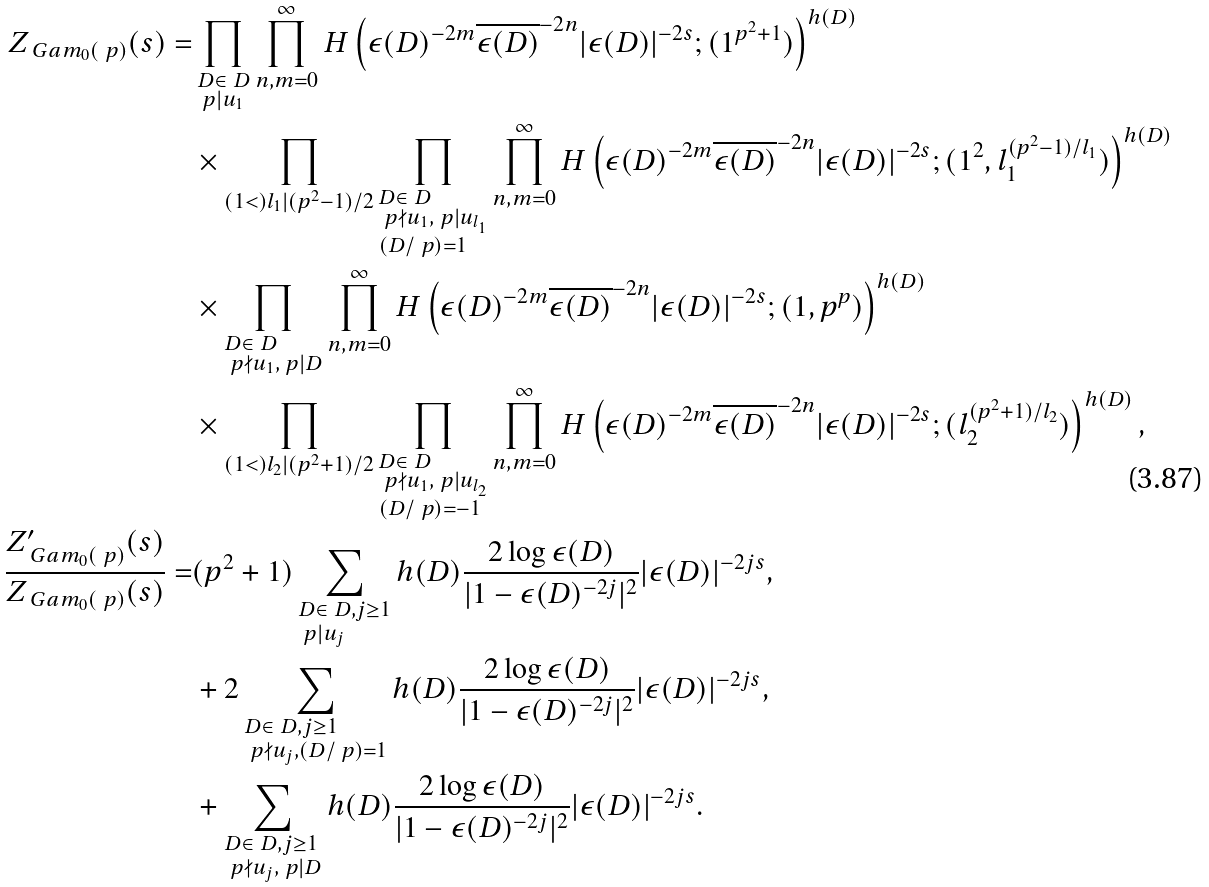Convert formula to latex. <formula><loc_0><loc_0><loc_500><loc_500>Z _ { \ G a m _ { 0 } ( \ p ) } ( s ) = & \prod _ { \begin{subarray} { c } D \in \ D \\ \ p | u _ { 1 } \end{subarray} } \prod _ { n , m = 0 } ^ { \infty } H \left ( \epsilon ( D ) ^ { - 2 m } \overline { \epsilon ( D ) } ^ { - 2 n } | \epsilon ( D ) | ^ { - 2 s } ; ( 1 ^ { p ^ { 2 } + 1 } ) \right ) ^ { h ( D ) } \\ & \times \prod _ { ( 1 < ) l _ { 1 } | ( p ^ { 2 } - 1 ) / 2 } \prod _ { \begin{subarray} { c } D \in \ D \\ \ p \nmid u _ { 1 } , \ p | u _ { l _ { 1 } } \\ ( D / \ p ) = 1 \end{subarray} } \prod _ { n , m = 0 } ^ { \infty } H \left ( \epsilon ( D ) ^ { - 2 m } \overline { \epsilon ( D ) } ^ { - 2 n } | \epsilon ( D ) | ^ { - 2 s } ; ( 1 ^ { 2 } , l _ { 1 } ^ { ( p ^ { 2 } - 1 ) / l _ { 1 } } ) \right ) ^ { h ( D ) } \\ & \times \prod _ { \begin{subarray} { c } D \in \ D \\ \ p \nmid u _ { 1 } , \ p | D \end{subarray} } \prod _ { n , m = 0 } ^ { \infty } H \left ( \epsilon ( D ) ^ { - 2 m } \overline { \epsilon ( D ) } ^ { - 2 n } | \epsilon ( D ) | ^ { - 2 s } ; ( 1 , p ^ { p } ) \right ) ^ { h ( D ) } \\ & \times \prod _ { ( 1 < ) l _ { 2 } | ( p ^ { 2 } + 1 ) / 2 } \prod _ { \begin{subarray} { c } D \in \ D \\ \ p \nmid u _ { 1 } , \ p | u _ { l _ { 2 } } \\ ( D / \ p ) = - 1 \end{subarray} } \prod _ { n , m = 0 } ^ { \infty } H \left ( \epsilon ( D ) ^ { - 2 m } \overline { \epsilon ( D ) } ^ { - 2 n } | \epsilon ( D ) | ^ { - 2 s } ; ( l _ { 2 } ^ { ( p ^ { 2 } + 1 ) / l _ { 2 } } ) \right ) ^ { h ( D ) } , \\ \frac { Z ^ { \prime } _ { \ G a m _ { 0 } ( \ p ) } ( s ) } { Z _ { \ G a m _ { 0 } ( \ p ) } ( s ) } = & ( p ^ { 2 } + 1 ) \sum _ { \begin{subarray} { c } D \in \ D , j \geq 1 \\ \ p | u _ { j } \end{subarray} } h ( D ) \frac { 2 \log { \epsilon ( D ) } } { | 1 - \epsilon ( D ) ^ { - 2 j } | ^ { 2 } } | \epsilon ( D ) | ^ { - 2 j s } , \\ & + 2 \sum _ { \begin{subarray} { c } D \in \ D , j \geq 1 \\ \ p \nmid u _ { j } , ( D / \ p ) = 1 \end{subarray} } h ( D ) \frac { 2 \log { \epsilon ( D ) } } { | 1 - \epsilon ( D ) ^ { - 2 j } | ^ { 2 } } | \epsilon ( D ) | ^ { - 2 j s } , \\ & + \sum _ { \begin{subarray} { c } D \in \ D , j \geq 1 \\ \ p \nmid u _ { j } , \ p | D \end{subarray} } h ( D ) \frac { 2 \log { \epsilon ( D ) } } { | 1 - \epsilon ( D ) ^ { - 2 j } | ^ { 2 } } | \epsilon ( D ) | ^ { - 2 j s } .</formula> 